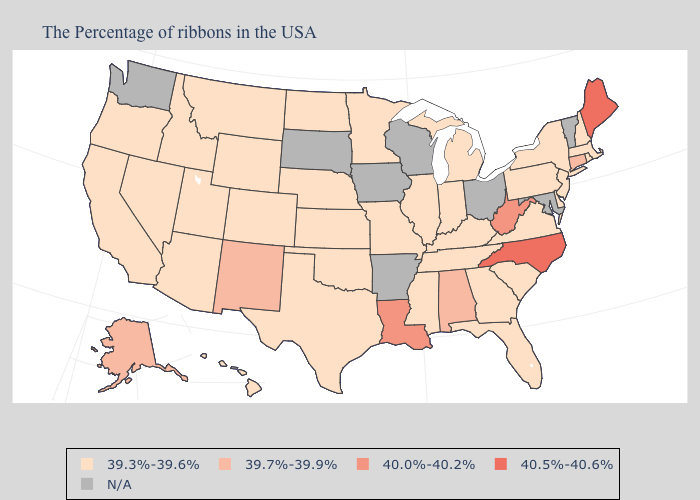What is the value of Minnesota?
Short answer required. 39.3%-39.6%. What is the value of Alaska?
Answer briefly. 39.7%-39.9%. Name the states that have a value in the range 40.5%-40.6%?
Concise answer only. Maine, North Carolina. Name the states that have a value in the range 40.5%-40.6%?
Be succinct. Maine, North Carolina. Name the states that have a value in the range N/A?
Keep it brief. Vermont, Maryland, Ohio, Wisconsin, Arkansas, Iowa, South Dakota, Washington. What is the highest value in the West ?
Keep it brief. 39.7%-39.9%. Name the states that have a value in the range 39.3%-39.6%?
Concise answer only. Massachusetts, Rhode Island, New Hampshire, New York, New Jersey, Delaware, Pennsylvania, Virginia, South Carolina, Florida, Georgia, Michigan, Kentucky, Indiana, Tennessee, Illinois, Mississippi, Missouri, Minnesota, Kansas, Nebraska, Oklahoma, Texas, North Dakota, Wyoming, Colorado, Utah, Montana, Arizona, Idaho, Nevada, California, Oregon, Hawaii. Among the states that border West Virginia , which have the highest value?
Write a very short answer. Pennsylvania, Virginia, Kentucky. What is the highest value in the West ?
Answer briefly. 39.7%-39.9%. What is the value of Texas?
Answer briefly. 39.3%-39.6%. What is the value of West Virginia?
Short answer required. 40.0%-40.2%. 